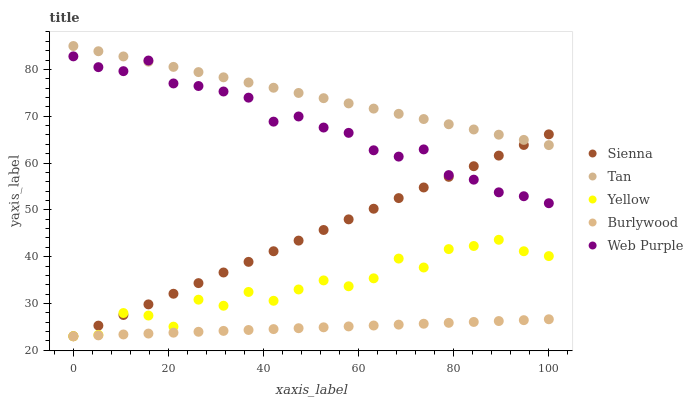Does Burlywood have the minimum area under the curve?
Answer yes or no. Yes. Does Tan have the maximum area under the curve?
Answer yes or no. Yes. Does Tan have the minimum area under the curve?
Answer yes or no. No. Does Burlywood have the maximum area under the curve?
Answer yes or no. No. Is Burlywood the smoothest?
Answer yes or no. Yes. Is Yellow the roughest?
Answer yes or no. Yes. Is Tan the smoothest?
Answer yes or no. No. Is Tan the roughest?
Answer yes or no. No. Does Sienna have the lowest value?
Answer yes or no. Yes. Does Tan have the lowest value?
Answer yes or no. No. Does Tan have the highest value?
Answer yes or no. Yes. Does Burlywood have the highest value?
Answer yes or no. No. Is Yellow less than Tan?
Answer yes or no. Yes. Is Tan greater than Yellow?
Answer yes or no. Yes. Does Burlywood intersect Sienna?
Answer yes or no. Yes. Is Burlywood less than Sienna?
Answer yes or no. No. Is Burlywood greater than Sienna?
Answer yes or no. No. Does Yellow intersect Tan?
Answer yes or no. No. 